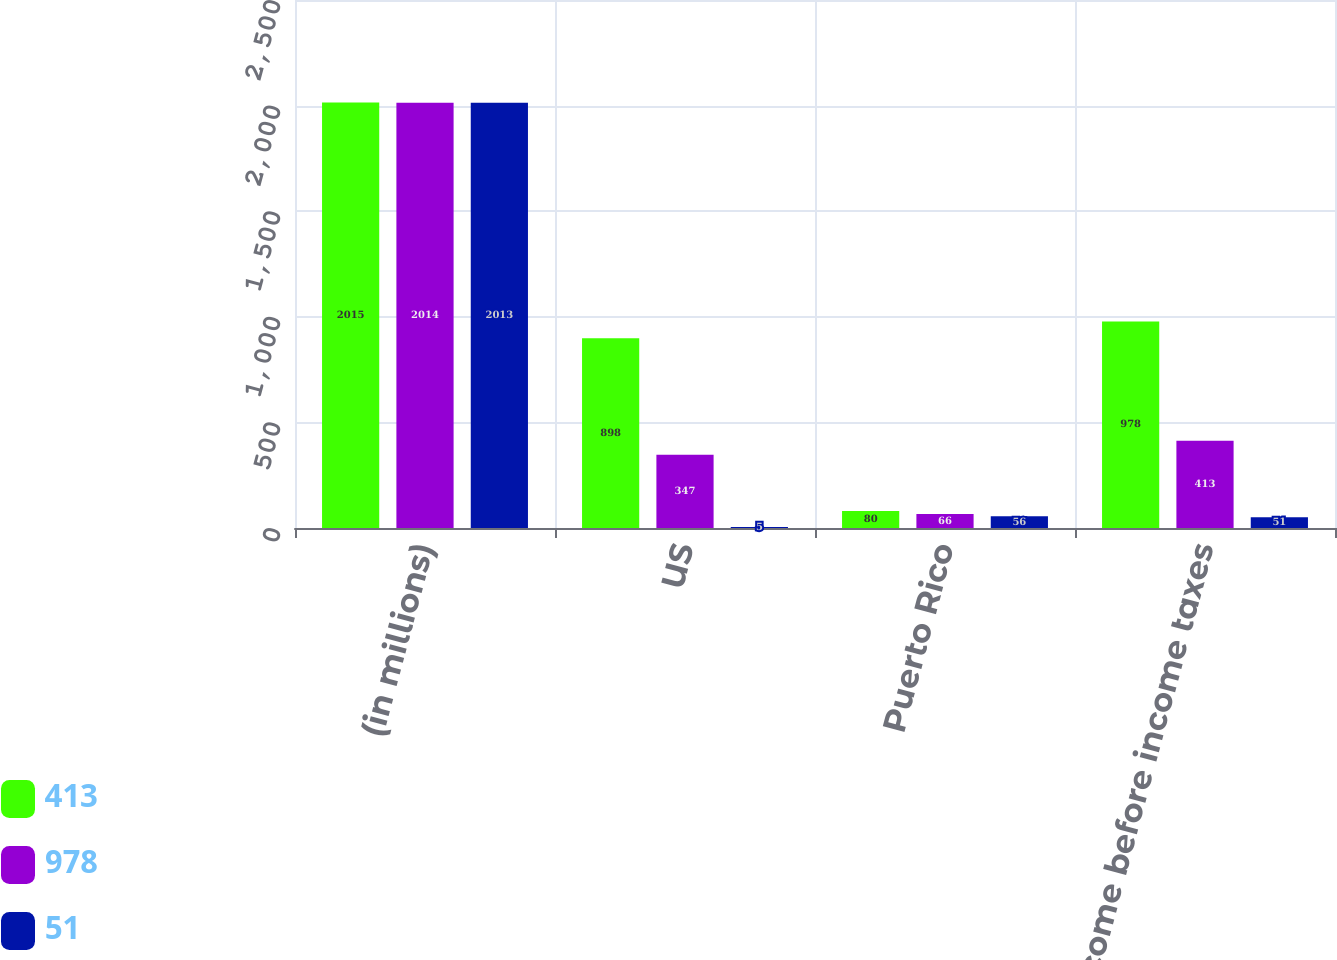Convert chart. <chart><loc_0><loc_0><loc_500><loc_500><stacked_bar_chart><ecel><fcel>(in millions)<fcel>US<fcel>Puerto Rico<fcel>Income before income taxes<nl><fcel>413<fcel>2015<fcel>898<fcel>80<fcel>978<nl><fcel>978<fcel>2014<fcel>347<fcel>66<fcel>413<nl><fcel>51<fcel>2013<fcel>5<fcel>56<fcel>51<nl></chart> 